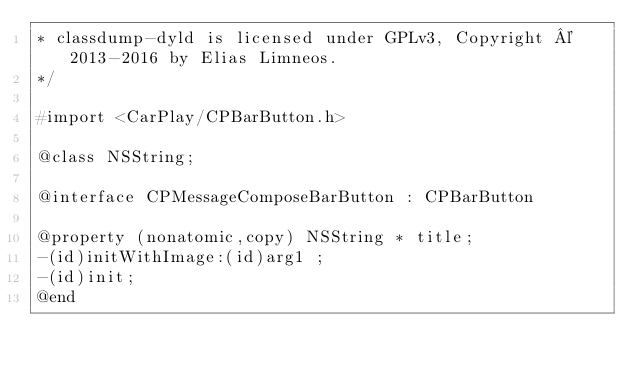<code> <loc_0><loc_0><loc_500><loc_500><_C_>* classdump-dyld is licensed under GPLv3, Copyright © 2013-2016 by Elias Limneos.
*/

#import <CarPlay/CPBarButton.h>

@class NSString;

@interface CPMessageComposeBarButton : CPBarButton

@property (nonatomic,copy) NSString * title; 
-(id)initWithImage:(id)arg1 ;
-(id)init;
@end

</code> 